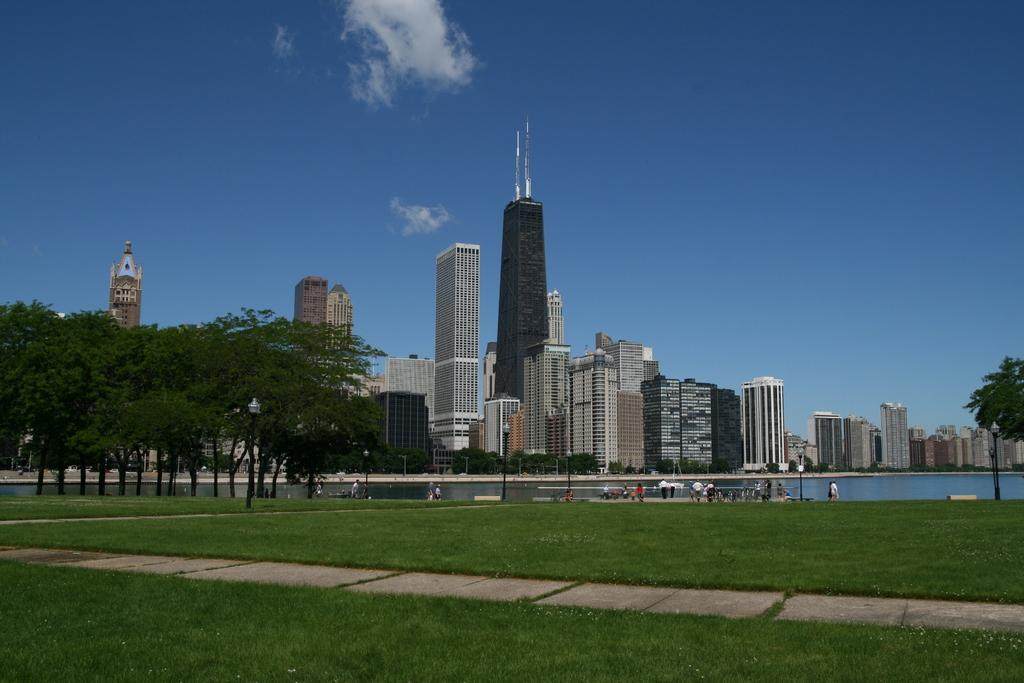What type of vegetation is present in the image? There is grass in the image. Who or what can be seen in the image? There are people in the image. What structures are visible in the image? There are poles in the image. What can be seen in the distance in the image? There are buildings, trees, water, and the sky visible in the background of the image. Where is the tray located in the image? There is no tray present in the image. How many sheep can be seen grazing on the grass in the image? There are no sheep present in the image. 